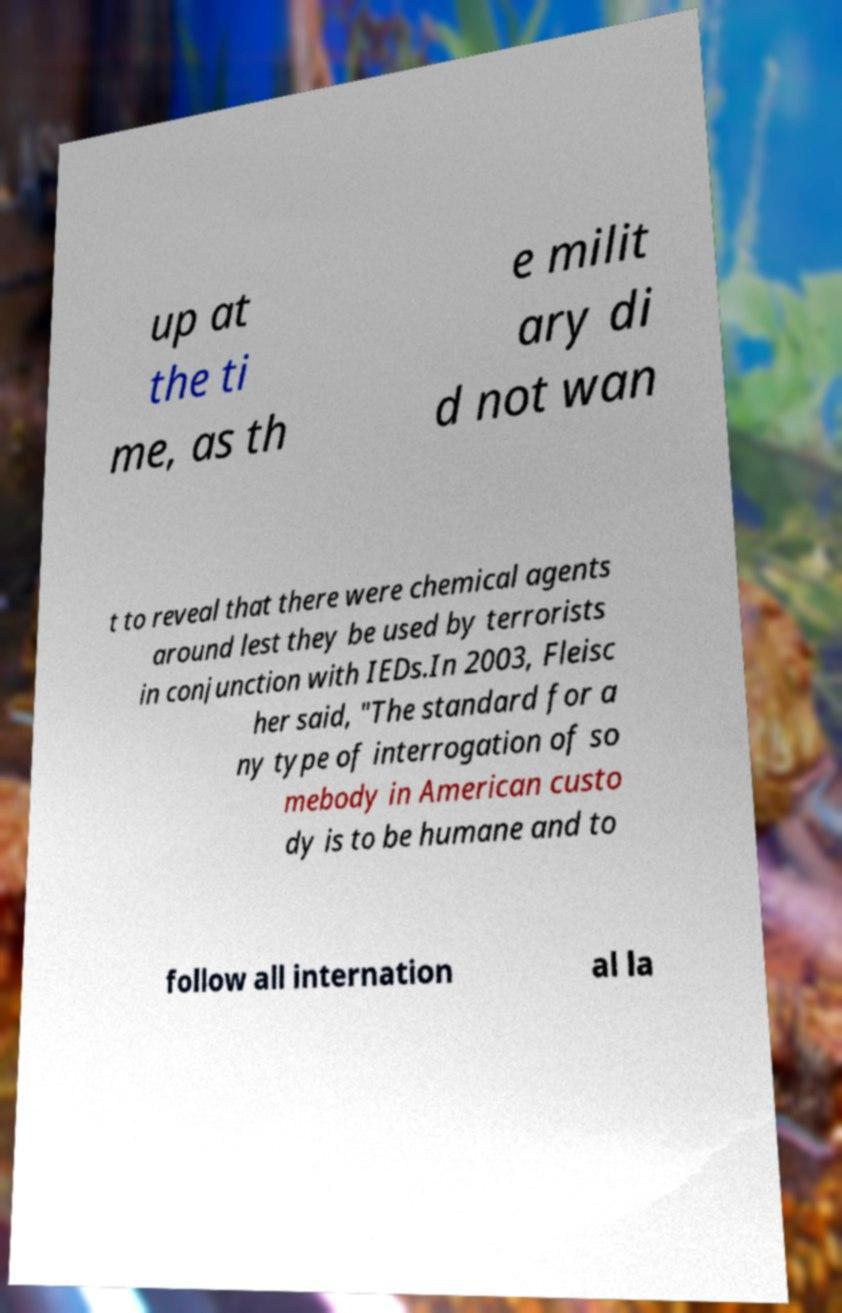Could you assist in decoding the text presented in this image and type it out clearly? up at the ti me, as th e milit ary di d not wan t to reveal that there were chemical agents around lest they be used by terrorists in conjunction with IEDs.In 2003, Fleisc her said, "The standard for a ny type of interrogation of so mebody in American custo dy is to be humane and to follow all internation al la 